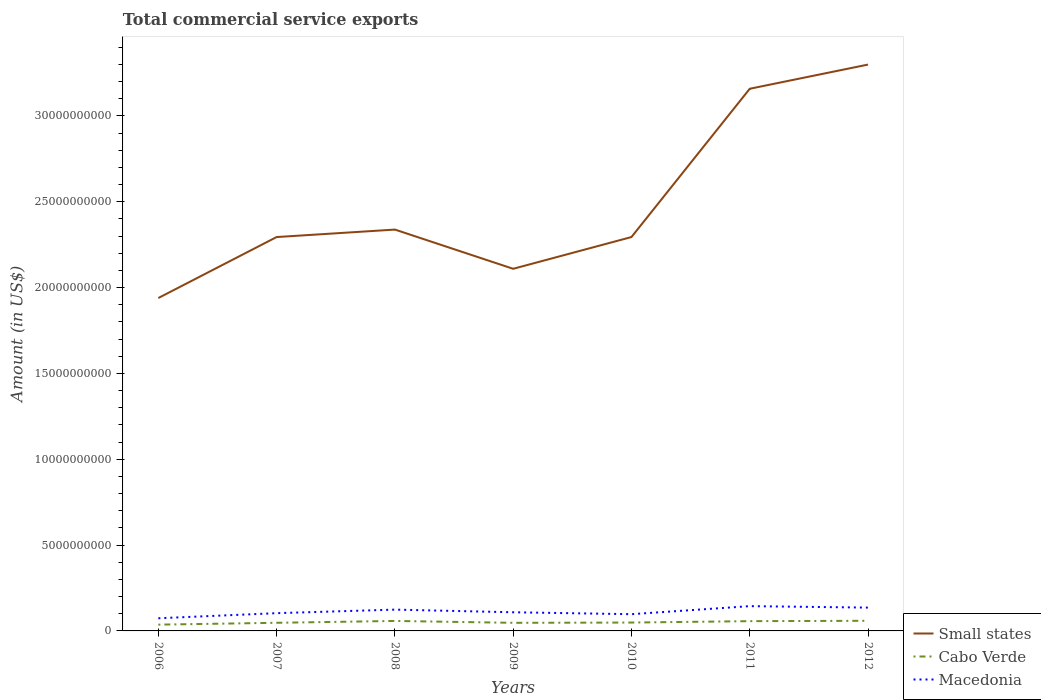How many different coloured lines are there?
Provide a succinct answer. 3. Across all years, what is the maximum total commercial service exports in Cabo Verde?
Offer a terse response. 3.66e+08. What is the total total commercial service exports in Small states in the graph?
Your answer should be very brief. -3.55e+09. What is the difference between the highest and the second highest total commercial service exports in Macedonia?
Your answer should be very brief. 7.05e+08. How many lines are there?
Your answer should be compact. 3. Are the values on the major ticks of Y-axis written in scientific E-notation?
Make the answer very short. No. Where does the legend appear in the graph?
Offer a terse response. Bottom right. How many legend labels are there?
Provide a succinct answer. 3. How are the legend labels stacked?
Your answer should be compact. Vertical. What is the title of the graph?
Keep it short and to the point. Total commercial service exports. Does "Belarus" appear as one of the legend labels in the graph?
Offer a very short reply. No. What is the label or title of the Y-axis?
Provide a succinct answer. Amount (in US$). What is the Amount (in US$) of Small states in 2006?
Provide a succinct answer. 1.94e+1. What is the Amount (in US$) in Cabo Verde in 2006?
Offer a very short reply. 3.66e+08. What is the Amount (in US$) of Macedonia in 2006?
Provide a short and direct response. 7.38e+08. What is the Amount (in US$) in Small states in 2007?
Provide a succinct answer. 2.29e+1. What is the Amount (in US$) of Cabo Verde in 2007?
Give a very brief answer. 4.74e+08. What is the Amount (in US$) in Macedonia in 2007?
Offer a very short reply. 1.03e+09. What is the Amount (in US$) of Small states in 2008?
Give a very brief answer. 2.34e+1. What is the Amount (in US$) of Cabo Verde in 2008?
Ensure brevity in your answer.  5.81e+08. What is the Amount (in US$) of Macedonia in 2008?
Make the answer very short. 1.24e+09. What is the Amount (in US$) in Small states in 2009?
Offer a very short reply. 2.11e+1. What is the Amount (in US$) of Cabo Verde in 2009?
Your response must be concise. 4.72e+08. What is the Amount (in US$) in Macedonia in 2009?
Make the answer very short. 1.09e+09. What is the Amount (in US$) in Small states in 2010?
Offer a terse response. 2.29e+1. What is the Amount (in US$) in Cabo Verde in 2010?
Provide a succinct answer. 4.87e+08. What is the Amount (in US$) of Macedonia in 2010?
Give a very brief answer. 9.75e+08. What is the Amount (in US$) of Small states in 2011?
Keep it short and to the point. 3.16e+1. What is the Amount (in US$) of Cabo Verde in 2011?
Offer a very short reply. 5.69e+08. What is the Amount (in US$) in Macedonia in 2011?
Your response must be concise. 1.44e+09. What is the Amount (in US$) in Small states in 2012?
Offer a very short reply. 3.30e+1. What is the Amount (in US$) of Cabo Verde in 2012?
Keep it short and to the point. 5.90e+08. What is the Amount (in US$) of Macedonia in 2012?
Offer a terse response. 1.36e+09. Across all years, what is the maximum Amount (in US$) in Small states?
Your answer should be very brief. 3.30e+1. Across all years, what is the maximum Amount (in US$) of Cabo Verde?
Your answer should be compact. 5.90e+08. Across all years, what is the maximum Amount (in US$) of Macedonia?
Your response must be concise. 1.44e+09. Across all years, what is the minimum Amount (in US$) of Small states?
Provide a succinct answer. 1.94e+1. Across all years, what is the minimum Amount (in US$) of Cabo Verde?
Provide a succinct answer. 3.66e+08. Across all years, what is the minimum Amount (in US$) in Macedonia?
Your answer should be compact. 7.38e+08. What is the total Amount (in US$) of Small states in the graph?
Provide a succinct answer. 1.74e+11. What is the total Amount (in US$) of Cabo Verde in the graph?
Ensure brevity in your answer.  3.54e+09. What is the total Amount (in US$) in Macedonia in the graph?
Offer a very short reply. 7.88e+09. What is the difference between the Amount (in US$) in Small states in 2006 and that in 2007?
Keep it short and to the point. -3.55e+09. What is the difference between the Amount (in US$) of Cabo Verde in 2006 and that in 2007?
Ensure brevity in your answer.  -1.08e+08. What is the difference between the Amount (in US$) of Macedonia in 2006 and that in 2007?
Keep it short and to the point. -2.96e+08. What is the difference between the Amount (in US$) in Small states in 2006 and that in 2008?
Provide a short and direct response. -3.99e+09. What is the difference between the Amount (in US$) in Cabo Verde in 2006 and that in 2008?
Offer a terse response. -2.15e+08. What is the difference between the Amount (in US$) of Macedonia in 2006 and that in 2008?
Your answer should be compact. -5.03e+08. What is the difference between the Amount (in US$) of Small states in 2006 and that in 2009?
Ensure brevity in your answer.  -1.70e+09. What is the difference between the Amount (in US$) in Cabo Verde in 2006 and that in 2009?
Your answer should be compact. -1.07e+08. What is the difference between the Amount (in US$) of Macedonia in 2006 and that in 2009?
Provide a short and direct response. -3.48e+08. What is the difference between the Amount (in US$) in Small states in 2006 and that in 2010?
Your answer should be very brief. -3.55e+09. What is the difference between the Amount (in US$) of Cabo Verde in 2006 and that in 2010?
Your response must be concise. -1.22e+08. What is the difference between the Amount (in US$) in Macedonia in 2006 and that in 2010?
Provide a short and direct response. -2.37e+08. What is the difference between the Amount (in US$) of Small states in 2006 and that in 2011?
Provide a short and direct response. -1.22e+1. What is the difference between the Amount (in US$) of Cabo Verde in 2006 and that in 2011?
Offer a very short reply. -2.03e+08. What is the difference between the Amount (in US$) of Macedonia in 2006 and that in 2011?
Your answer should be very brief. -7.05e+08. What is the difference between the Amount (in US$) in Small states in 2006 and that in 2012?
Ensure brevity in your answer.  -1.36e+1. What is the difference between the Amount (in US$) of Cabo Verde in 2006 and that in 2012?
Ensure brevity in your answer.  -2.24e+08. What is the difference between the Amount (in US$) of Macedonia in 2006 and that in 2012?
Your response must be concise. -6.21e+08. What is the difference between the Amount (in US$) in Small states in 2007 and that in 2008?
Keep it short and to the point. -4.35e+08. What is the difference between the Amount (in US$) of Cabo Verde in 2007 and that in 2008?
Make the answer very short. -1.07e+08. What is the difference between the Amount (in US$) in Macedonia in 2007 and that in 2008?
Offer a terse response. -2.07e+08. What is the difference between the Amount (in US$) of Small states in 2007 and that in 2009?
Your answer should be very brief. 1.85e+09. What is the difference between the Amount (in US$) of Cabo Verde in 2007 and that in 2009?
Your answer should be compact. 1.47e+06. What is the difference between the Amount (in US$) in Macedonia in 2007 and that in 2009?
Give a very brief answer. -5.23e+07. What is the difference between the Amount (in US$) of Small states in 2007 and that in 2010?
Offer a terse response. 1.28e+05. What is the difference between the Amount (in US$) in Cabo Verde in 2007 and that in 2010?
Keep it short and to the point. -1.36e+07. What is the difference between the Amount (in US$) of Macedonia in 2007 and that in 2010?
Provide a short and direct response. 5.94e+07. What is the difference between the Amount (in US$) of Small states in 2007 and that in 2011?
Provide a succinct answer. -8.64e+09. What is the difference between the Amount (in US$) of Cabo Verde in 2007 and that in 2011?
Provide a succinct answer. -9.52e+07. What is the difference between the Amount (in US$) of Macedonia in 2007 and that in 2011?
Your answer should be very brief. -4.09e+08. What is the difference between the Amount (in US$) of Small states in 2007 and that in 2012?
Make the answer very short. -1.00e+1. What is the difference between the Amount (in US$) of Cabo Verde in 2007 and that in 2012?
Your answer should be compact. -1.16e+08. What is the difference between the Amount (in US$) of Macedonia in 2007 and that in 2012?
Offer a very short reply. -3.24e+08. What is the difference between the Amount (in US$) of Small states in 2008 and that in 2009?
Give a very brief answer. 2.28e+09. What is the difference between the Amount (in US$) of Cabo Verde in 2008 and that in 2009?
Your answer should be very brief. 1.09e+08. What is the difference between the Amount (in US$) in Macedonia in 2008 and that in 2009?
Your answer should be compact. 1.55e+08. What is the difference between the Amount (in US$) in Small states in 2008 and that in 2010?
Offer a terse response. 4.35e+08. What is the difference between the Amount (in US$) in Cabo Verde in 2008 and that in 2010?
Make the answer very short. 9.37e+07. What is the difference between the Amount (in US$) in Macedonia in 2008 and that in 2010?
Provide a short and direct response. 2.66e+08. What is the difference between the Amount (in US$) of Small states in 2008 and that in 2011?
Give a very brief answer. -8.20e+09. What is the difference between the Amount (in US$) in Cabo Verde in 2008 and that in 2011?
Ensure brevity in your answer.  1.21e+07. What is the difference between the Amount (in US$) of Macedonia in 2008 and that in 2011?
Ensure brevity in your answer.  -2.02e+08. What is the difference between the Amount (in US$) of Small states in 2008 and that in 2012?
Provide a succinct answer. -9.61e+09. What is the difference between the Amount (in US$) of Cabo Verde in 2008 and that in 2012?
Keep it short and to the point. -8.97e+06. What is the difference between the Amount (in US$) of Macedonia in 2008 and that in 2012?
Ensure brevity in your answer.  -1.18e+08. What is the difference between the Amount (in US$) of Small states in 2009 and that in 2010?
Offer a very short reply. -1.85e+09. What is the difference between the Amount (in US$) in Cabo Verde in 2009 and that in 2010?
Offer a terse response. -1.51e+07. What is the difference between the Amount (in US$) of Macedonia in 2009 and that in 2010?
Give a very brief answer. 1.12e+08. What is the difference between the Amount (in US$) in Small states in 2009 and that in 2011?
Give a very brief answer. -1.05e+1. What is the difference between the Amount (in US$) of Cabo Verde in 2009 and that in 2011?
Provide a short and direct response. -9.67e+07. What is the difference between the Amount (in US$) in Macedonia in 2009 and that in 2011?
Offer a terse response. -3.57e+08. What is the difference between the Amount (in US$) in Small states in 2009 and that in 2012?
Ensure brevity in your answer.  -1.19e+1. What is the difference between the Amount (in US$) in Cabo Verde in 2009 and that in 2012?
Provide a succinct answer. -1.18e+08. What is the difference between the Amount (in US$) in Macedonia in 2009 and that in 2012?
Your response must be concise. -2.72e+08. What is the difference between the Amount (in US$) in Small states in 2010 and that in 2011?
Offer a very short reply. -8.64e+09. What is the difference between the Amount (in US$) in Cabo Verde in 2010 and that in 2011?
Your response must be concise. -8.16e+07. What is the difference between the Amount (in US$) of Macedonia in 2010 and that in 2011?
Your answer should be very brief. -4.69e+08. What is the difference between the Amount (in US$) of Small states in 2010 and that in 2012?
Your response must be concise. -1.00e+1. What is the difference between the Amount (in US$) of Cabo Verde in 2010 and that in 2012?
Provide a short and direct response. -1.03e+08. What is the difference between the Amount (in US$) in Macedonia in 2010 and that in 2012?
Make the answer very short. -3.84e+08. What is the difference between the Amount (in US$) of Small states in 2011 and that in 2012?
Your response must be concise. -1.41e+09. What is the difference between the Amount (in US$) of Cabo Verde in 2011 and that in 2012?
Offer a terse response. -2.10e+07. What is the difference between the Amount (in US$) in Macedonia in 2011 and that in 2012?
Ensure brevity in your answer.  8.47e+07. What is the difference between the Amount (in US$) in Small states in 2006 and the Amount (in US$) in Cabo Verde in 2007?
Ensure brevity in your answer.  1.89e+1. What is the difference between the Amount (in US$) in Small states in 2006 and the Amount (in US$) in Macedonia in 2007?
Your answer should be compact. 1.84e+1. What is the difference between the Amount (in US$) of Cabo Verde in 2006 and the Amount (in US$) of Macedonia in 2007?
Give a very brief answer. -6.69e+08. What is the difference between the Amount (in US$) in Small states in 2006 and the Amount (in US$) in Cabo Verde in 2008?
Your answer should be compact. 1.88e+1. What is the difference between the Amount (in US$) in Small states in 2006 and the Amount (in US$) in Macedonia in 2008?
Offer a terse response. 1.81e+1. What is the difference between the Amount (in US$) in Cabo Verde in 2006 and the Amount (in US$) in Macedonia in 2008?
Keep it short and to the point. -8.75e+08. What is the difference between the Amount (in US$) in Small states in 2006 and the Amount (in US$) in Cabo Verde in 2009?
Provide a short and direct response. 1.89e+1. What is the difference between the Amount (in US$) in Small states in 2006 and the Amount (in US$) in Macedonia in 2009?
Ensure brevity in your answer.  1.83e+1. What is the difference between the Amount (in US$) in Cabo Verde in 2006 and the Amount (in US$) in Macedonia in 2009?
Give a very brief answer. -7.21e+08. What is the difference between the Amount (in US$) of Small states in 2006 and the Amount (in US$) of Cabo Verde in 2010?
Provide a succinct answer. 1.89e+1. What is the difference between the Amount (in US$) in Small states in 2006 and the Amount (in US$) in Macedonia in 2010?
Make the answer very short. 1.84e+1. What is the difference between the Amount (in US$) in Cabo Verde in 2006 and the Amount (in US$) in Macedonia in 2010?
Your response must be concise. -6.09e+08. What is the difference between the Amount (in US$) of Small states in 2006 and the Amount (in US$) of Cabo Verde in 2011?
Keep it short and to the point. 1.88e+1. What is the difference between the Amount (in US$) of Small states in 2006 and the Amount (in US$) of Macedonia in 2011?
Your answer should be very brief. 1.79e+1. What is the difference between the Amount (in US$) in Cabo Verde in 2006 and the Amount (in US$) in Macedonia in 2011?
Provide a succinct answer. -1.08e+09. What is the difference between the Amount (in US$) in Small states in 2006 and the Amount (in US$) in Cabo Verde in 2012?
Give a very brief answer. 1.88e+1. What is the difference between the Amount (in US$) of Small states in 2006 and the Amount (in US$) of Macedonia in 2012?
Your answer should be very brief. 1.80e+1. What is the difference between the Amount (in US$) of Cabo Verde in 2006 and the Amount (in US$) of Macedonia in 2012?
Make the answer very short. -9.93e+08. What is the difference between the Amount (in US$) in Small states in 2007 and the Amount (in US$) in Cabo Verde in 2008?
Provide a succinct answer. 2.24e+1. What is the difference between the Amount (in US$) in Small states in 2007 and the Amount (in US$) in Macedonia in 2008?
Your answer should be very brief. 2.17e+1. What is the difference between the Amount (in US$) in Cabo Verde in 2007 and the Amount (in US$) in Macedonia in 2008?
Provide a succinct answer. -7.67e+08. What is the difference between the Amount (in US$) in Small states in 2007 and the Amount (in US$) in Cabo Verde in 2009?
Your answer should be very brief. 2.25e+1. What is the difference between the Amount (in US$) of Small states in 2007 and the Amount (in US$) of Macedonia in 2009?
Give a very brief answer. 2.19e+1. What is the difference between the Amount (in US$) in Cabo Verde in 2007 and the Amount (in US$) in Macedonia in 2009?
Make the answer very short. -6.13e+08. What is the difference between the Amount (in US$) of Small states in 2007 and the Amount (in US$) of Cabo Verde in 2010?
Offer a terse response. 2.25e+1. What is the difference between the Amount (in US$) in Small states in 2007 and the Amount (in US$) in Macedonia in 2010?
Your answer should be very brief. 2.20e+1. What is the difference between the Amount (in US$) of Cabo Verde in 2007 and the Amount (in US$) of Macedonia in 2010?
Your response must be concise. -5.01e+08. What is the difference between the Amount (in US$) of Small states in 2007 and the Amount (in US$) of Cabo Verde in 2011?
Your response must be concise. 2.24e+1. What is the difference between the Amount (in US$) of Small states in 2007 and the Amount (in US$) of Macedonia in 2011?
Ensure brevity in your answer.  2.15e+1. What is the difference between the Amount (in US$) of Cabo Verde in 2007 and the Amount (in US$) of Macedonia in 2011?
Make the answer very short. -9.70e+08. What is the difference between the Amount (in US$) of Small states in 2007 and the Amount (in US$) of Cabo Verde in 2012?
Your response must be concise. 2.24e+1. What is the difference between the Amount (in US$) of Small states in 2007 and the Amount (in US$) of Macedonia in 2012?
Your response must be concise. 2.16e+1. What is the difference between the Amount (in US$) of Cabo Verde in 2007 and the Amount (in US$) of Macedonia in 2012?
Provide a short and direct response. -8.85e+08. What is the difference between the Amount (in US$) in Small states in 2008 and the Amount (in US$) in Cabo Verde in 2009?
Keep it short and to the point. 2.29e+1. What is the difference between the Amount (in US$) of Small states in 2008 and the Amount (in US$) of Macedonia in 2009?
Give a very brief answer. 2.23e+1. What is the difference between the Amount (in US$) of Cabo Verde in 2008 and the Amount (in US$) of Macedonia in 2009?
Give a very brief answer. -5.05e+08. What is the difference between the Amount (in US$) of Small states in 2008 and the Amount (in US$) of Cabo Verde in 2010?
Keep it short and to the point. 2.29e+1. What is the difference between the Amount (in US$) in Small states in 2008 and the Amount (in US$) in Macedonia in 2010?
Keep it short and to the point. 2.24e+1. What is the difference between the Amount (in US$) in Cabo Verde in 2008 and the Amount (in US$) in Macedonia in 2010?
Provide a short and direct response. -3.94e+08. What is the difference between the Amount (in US$) of Small states in 2008 and the Amount (in US$) of Cabo Verde in 2011?
Give a very brief answer. 2.28e+1. What is the difference between the Amount (in US$) of Small states in 2008 and the Amount (in US$) of Macedonia in 2011?
Your answer should be compact. 2.19e+1. What is the difference between the Amount (in US$) of Cabo Verde in 2008 and the Amount (in US$) of Macedonia in 2011?
Offer a terse response. -8.62e+08. What is the difference between the Amount (in US$) in Small states in 2008 and the Amount (in US$) in Cabo Verde in 2012?
Your answer should be very brief. 2.28e+1. What is the difference between the Amount (in US$) in Small states in 2008 and the Amount (in US$) in Macedonia in 2012?
Your answer should be very brief. 2.20e+1. What is the difference between the Amount (in US$) of Cabo Verde in 2008 and the Amount (in US$) of Macedonia in 2012?
Make the answer very short. -7.78e+08. What is the difference between the Amount (in US$) in Small states in 2009 and the Amount (in US$) in Cabo Verde in 2010?
Provide a succinct answer. 2.06e+1. What is the difference between the Amount (in US$) in Small states in 2009 and the Amount (in US$) in Macedonia in 2010?
Provide a succinct answer. 2.01e+1. What is the difference between the Amount (in US$) in Cabo Verde in 2009 and the Amount (in US$) in Macedonia in 2010?
Offer a terse response. -5.02e+08. What is the difference between the Amount (in US$) in Small states in 2009 and the Amount (in US$) in Cabo Verde in 2011?
Offer a terse response. 2.05e+1. What is the difference between the Amount (in US$) of Small states in 2009 and the Amount (in US$) of Macedonia in 2011?
Your answer should be compact. 1.96e+1. What is the difference between the Amount (in US$) in Cabo Verde in 2009 and the Amount (in US$) in Macedonia in 2011?
Your response must be concise. -9.71e+08. What is the difference between the Amount (in US$) of Small states in 2009 and the Amount (in US$) of Cabo Verde in 2012?
Keep it short and to the point. 2.05e+1. What is the difference between the Amount (in US$) of Small states in 2009 and the Amount (in US$) of Macedonia in 2012?
Offer a terse response. 1.97e+1. What is the difference between the Amount (in US$) of Cabo Verde in 2009 and the Amount (in US$) of Macedonia in 2012?
Your answer should be compact. -8.86e+08. What is the difference between the Amount (in US$) in Small states in 2010 and the Amount (in US$) in Cabo Verde in 2011?
Give a very brief answer. 2.24e+1. What is the difference between the Amount (in US$) in Small states in 2010 and the Amount (in US$) in Macedonia in 2011?
Offer a terse response. 2.15e+1. What is the difference between the Amount (in US$) of Cabo Verde in 2010 and the Amount (in US$) of Macedonia in 2011?
Offer a very short reply. -9.56e+08. What is the difference between the Amount (in US$) of Small states in 2010 and the Amount (in US$) of Cabo Verde in 2012?
Provide a short and direct response. 2.24e+1. What is the difference between the Amount (in US$) of Small states in 2010 and the Amount (in US$) of Macedonia in 2012?
Offer a very short reply. 2.16e+1. What is the difference between the Amount (in US$) of Cabo Verde in 2010 and the Amount (in US$) of Macedonia in 2012?
Ensure brevity in your answer.  -8.71e+08. What is the difference between the Amount (in US$) in Small states in 2011 and the Amount (in US$) in Cabo Verde in 2012?
Ensure brevity in your answer.  3.10e+1. What is the difference between the Amount (in US$) of Small states in 2011 and the Amount (in US$) of Macedonia in 2012?
Keep it short and to the point. 3.02e+1. What is the difference between the Amount (in US$) in Cabo Verde in 2011 and the Amount (in US$) in Macedonia in 2012?
Give a very brief answer. -7.90e+08. What is the average Amount (in US$) in Small states per year?
Keep it short and to the point. 2.49e+1. What is the average Amount (in US$) of Cabo Verde per year?
Ensure brevity in your answer.  5.06e+08. What is the average Amount (in US$) in Macedonia per year?
Offer a very short reply. 1.13e+09. In the year 2006, what is the difference between the Amount (in US$) in Small states and Amount (in US$) in Cabo Verde?
Make the answer very short. 1.90e+1. In the year 2006, what is the difference between the Amount (in US$) of Small states and Amount (in US$) of Macedonia?
Your response must be concise. 1.87e+1. In the year 2006, what is the difference between the Amount (in US$) of Cabo Verde and Amount (in US$) of Macedonia?
Your answer should be very brief. -3.72e+08. In the year 2007, what is the difference between the Amount (in US$) of Small states and Amount (in US$) of Cabo Verde?
Offer a very short reply. 2.25e+1. In the year 2007, what is the difference between the Amount (in US$) in Small states and Amount (in US$) in Macedonia?
Give a very brief answer. 2.19e+1. In the year 2007, what is the difference between the Amount (in US$) of Cabo Verde and Amount (in US$) of Macedonia?
Offer a terse response. -5.60e+08. In the year 2008, what is the difference between the Amount (in US$) in Small states and Amount (in US$) in Cabo Verde?
Your response must be concise. 2.28e+1. In the year 2008, what is the difference between the Amount (in US$) in Small states and Amount (in US$) in Macedonia?
Your response must be concise. 2.21e+1. In the year 2008, what is the difference between the Amount (in US$) in Cabo Verde and Amount (in US$) in Macedonia?
Keep it short and to the point. -6.60e+08. In the year 2009, what is the difference between the Amount (in US$) in Small states and Amount (in US$) in Cabo Verde?
Ensure brevity in your answer.  2.06e+1. In the year 2009, what is the difference between the Amount (in US$) of Small states and Amount (in US$) of Macedonia?
Make the answer very short. 2.00e+1. In the year 2009, what is the difference between the Amount (in US$) in Cabo Verde and Amount (in US$) in Macedonia?
Provide a succinct answer. -6.14e+08. In the year 2010, what is the difference between the Amount (in US$) of Small states and Amount (in US$) of Cabo Verde?
Provide a succinct answer. 2.25e+1. In the year 2010, what is the difference between the Amount (in US$) of Small states and Amount (in US$) of Macedonia?
Offer a terse response. 2.20e+1. In the year 2010, what is the difference between the Amount (in US$) of Cabo Verde and Amount (in US$) of Macedonia?
Your answer should be compact. -4.87e+08. In the year 2011, what is the difference between the Amount (in US$) of Small states and Amount (in US$) of Cabo Verde?
Provide a short and direct response. 3.10e+1. In the year 2011, what is the difference between the Amount (in US$) in Small states and Amount (in US$) in Macedonia?
Give a very brief answer. 3.01e+1. In the year 2011, what is the difference between the Amount (in US$) of Cabo Verde and Amount (in US$) of Macedonia?
Your response must be concise. -8.74e+08. In the year 2012, what is the difference between the Amount (in US$) in Small states and Amount (in US$) in Cabo Verde?
Provide a succinct answer. 3.24e+1. In the year 2012, what is the difference between the Amount (in US$) in Small states and Amount (in US$) in Macedonia?
Your answer should be compact. 3.16e+1. In the year 2012, what is the difference between the Amount (in US$) of Cabo Verde and Amount (in US$) of Macedonia?
Offer a very short reply. -7.69e+08. What is the ratio of the Amount (in US$) in Small states in 2006 to that in 2007?
Ensure brevity in your answer.  0.85. What is the ratio of the Amount (in US$) in Cabo Verde in 2006 to that in 2007?
Provide a succinct answer. 0.77. What is the ratio of the Amount (in US$) of Macedonia in 2006 to that in 2007?
Your answer should be compact. 0.71. What is the ratio of the Amount (in US$) in Small states in 2006 to that in 2008?
Your response must be concise. 0.83. What is the ratio of the Amount (in US$) in Cabo Verde in 2006 to that in 2008?
Give a very brief answer. 0.63. What is the ratio of the Amount (in US$) of Macedonia in 2006 to that in 2008?
Keep it short and to the point. 0.59. What is the ratio of the Amount (in US$) in Small states in 2006 to that in 2009?
Your answer should be very brief. 0.92. What is the ratio of the Amount (in US$) of Cabo Verde in 2006 to that in 2009?
Make the answer very short. 0.77. What is the ratio of the Amount (in US$) in Macedonia in 2006 to that in 2009?
Provide a short and direct response. 0.68. What is the ratio of the Amount (in US$) in Small states in 2006 to that in 2010?
Offer a terse response. 0.85. What is the ratio of the Amount (in US$) of Cabo Verde in 2006 to that in 2010?
Give a very brief answer. 0.75. What is the ratio of the Amount (in US$) of Macedonia in 2006 to that in 2010?
Provide a succinct answer. 0.76. What is the ratio of the Amount (in US$) of Small states in 2006 to that in 2011?
Give a very brief answer. 0.61. What is the ratio of the Amount (in US$) in Cabo Verde in 2006 to that in 2011?
Give a very brief answer. 0.64. What is the ratio of the Amount (in US$) in Macedonia in 2006 to that in 2011?
Provide a succinct answer. 0.51. What is the ratio of the Amount (in US$) in Small states in 2006 to that in 2012?
Provide a short and direct response. 0.59. What is the ratio of the Amount (in US$) in Cabo Verde in 2006 to that in 2012?
Ensure brevity in your answer.  0.62. What is the ratio of the Amount (in US$) of Macedonia in 2006 to that in 2012?
Offer a very short reply. 0.54. What is the ratio of the Amount (in US$) in Small states in 2007 to that in 2008?
Provide a succinct answer. 0.98. What is the ratio of the Amount (in US$) in Cabo Verde in 2007 to that in 2008?
Ensure brevity in your answer.  0.82. What is the ratio of the Amount (in US$) in Macedonia in 2007 to that in 2008?
Your response must be concise. 0.83. What is the ratio of the Amount (in US$) in Small states in 2007 to that in 2009?
Offer a very short reply. 1.09. What is the ratio of the Amount (in US$) of Cabo Verde in 2007 to that in 2009?
Provide a succinct answer. 1. What is the ratio of the Amount (in US$) of Macedonia in 2007 to that in 2009?
Offer a very short reply. 0.95. What is the ratio of the Amount (in US$) in Macedonia in 2007 to that in 2010?
Your answer should be compact. 1.06. What is the ratio of the Amount (in US$) of Small states in 2007 to that in 2011?
Make the answer very short. 0.73. What is the ratio of the Amount (in US$) of Cabo Verde in 2007 to that in 2011?
Ensure brevity in your answer.  0.83. What is the ratio of the Amount (in US$) in Macedonia in 2007 to that in 2011?
Keep it short and to the point. 0.72. What is the ratio of the Amount (in US$) in Small states in 2007 to that in 2012?
Ensure brevity in your answer.  0.7. What is the ratio of the Amount (in US$) in Cabo Verde in 2007 to that in 2012?
Your answer should be compact. 0.8. What is the ratio of the Amount (in US$) in Macedonia in 2007 to that in 2012?
Keep it short and to the point. 0.76. What is the ratio of the Amount (in US$) in Small states in 2008 to that in 2009?
Your answer should be compact. 1.11. What is the ratio of the Amount (in US$) of Cabo Verde in 2008 to that in 2009?
Make the answer very short. 1.23. What is the ratio of the Amount (in US$) of Macedonia in 2008 to that in 2009?
Ensure brevity in your answer.  1.14. What is the ratio of the Amount (in US$) of Small states in 2008 to that in 2010?
Your answer should be very brief. 1.02. What is the ratio of the Amount (in US$) of Cabo Verde in 2008 to that in 2010?
Your answer should be compact. 1.19. What is the ratio of the Amount (in US$) of Macedonia in 2008 to that in 2010?
Your response must be concise. 1.27. What is the ratio of the Amount (in US$) in Small states in 2008 to that in 2011?
Ensure brevity in your answer.  0.74. What is the ratio of the Amount (in US$) in Cabo Verde in 2008 to that in 2011?
Your response must be concise. 1.02. What is the ratio of the Amount (in US$) of Macedonia in 2008 to that in 2011?
Provide a short and direct response. 0.86. What is the ratio of the Amount (in US$) in Small states in 2008 to that in 2012?
Make the answer very short. 0.71. What is the ratio of the Amount (in US$) of Cabo Verde in 2008 to that in 2012?
Your response must be concise. 0.98. What is the ratio of the Amount (in US$) in Macedonia in 2008 to that in 2012?
Your response must be concise. 0.91. What is the ratio of the Amount (in US$) of Small states in 2009 to that in 2010?
Make the answer very short. 0.92. What is the ratio of the Amount (in US$) of Cabo Verde in 2009 to that in 2010?
Keep it short and to the point. 0.97. What is the ratio of the Amount (in US$) of Macedonia in 2009 to that in 2010?
Your answer should be very brief. 1.11. What is the ratio of the Amount (in US$) of Small states in 2009 to that in 2011?
Your answer should be very brief. 0.67. What is the ratio of the Amount (in US$) in Cabo Verde in 2009 to that in 2011?
Make the answer very short. 0.83. What is the ratio of the Amount (in US$) of Macedonia in 2009 to that in 2011?
Offer a very short reply. 0.75. What is the ratio of the Amount (in US$) of Small states in 2009 to that in 2012?
Keep it short and to the point. 0.64. What is the ratio of the Amount (in US$) in Cabo Verde in 2009 to that in 2012?
Your answer should be compact. 0.8. What is the ratio of the Amount (in US$) of Macedonia in 2009 to that in 2012?
Provide a short and direct response. 0.8. What is the ratio of the Amount (in US$) in Small states in 2010 to that in 2011?
Your answer should be compact. 0.73. What is the ratio of the Amount (in US$) of Cabo Verde in 2010 to that in 2011?
Make the answer very short. 0.86. What is the ratio of the Amount (in US$) of Macedonia in 2010 to that in 2011?
Make the answer very short. 0.68. What is the ratio of the Amount (in US$) in Small states in 2010 to that in 2012?
Provide a short and direct response. 0.7. What is the ratio of the Amount (in US$) of Cabo Verde in 2010 to that in 2012?
Provide a succinct answer. 0.83. What is the ratio of the Amount (in US$) in Macedonia in 2010 to that in 2012?
Give a very brief answer. 0.72. What is the ratio of the Amount (in US$) of Small states in 2011 to that in 2012?
Your answer should be very brief. 0.96. What is the ratio of the Amount (in US$) of Macedonia in 2011 to that in 2012?
Your answer should be very brief. 1.06. What is the difference between the highest and the second highest Amount (in US$) of Small states?
Ensure brevity in your answer.  1.41e+09. What is the difference between the highest and the second highest Amount (in US$) in Cabo Verde?
Keep it short and to the point. 8.97e+06. What is the difference between the highest and the second highest Amount (in US$) in Macedonia?
Offer a terse response. 8.47e+07. What is the difference between the highest and the lowest Amount (in US$) of Small states?
Keep it short and to the point. 1.36e+1. What is the difference between the highest and the lowest Amount (in US$) of Cabo Verde?
Offer a very short reply. 2.24e+08. What is the difference between the highest and the lowest Amount (in US$) in Macedonia?
Your response must be concise. 7.05e+08. 